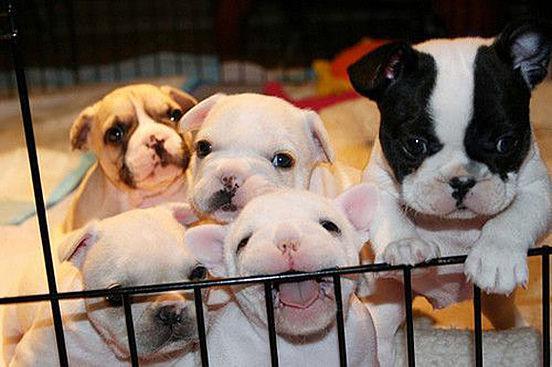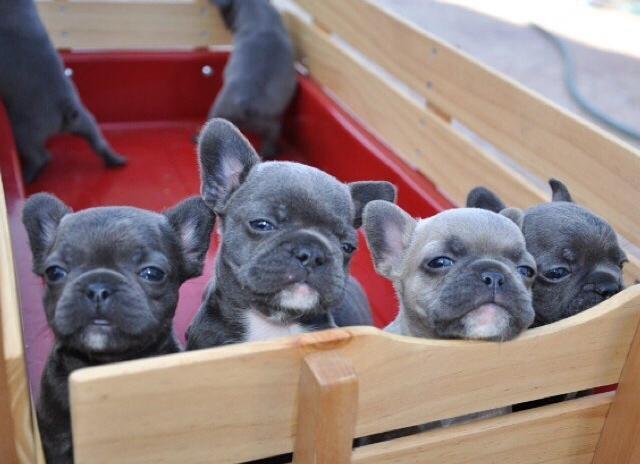The first image is the image on the left, the second image is the image on the right. Given the left and right images, does the statement "There are at least four animals in the image on the right." hold true? Answer yes or no. Yes. The first image is the image on the left, the second image is the image on the right. For the images shown, is this caption "The dogs on the left are lined up." true? Answer yes or no. No. 